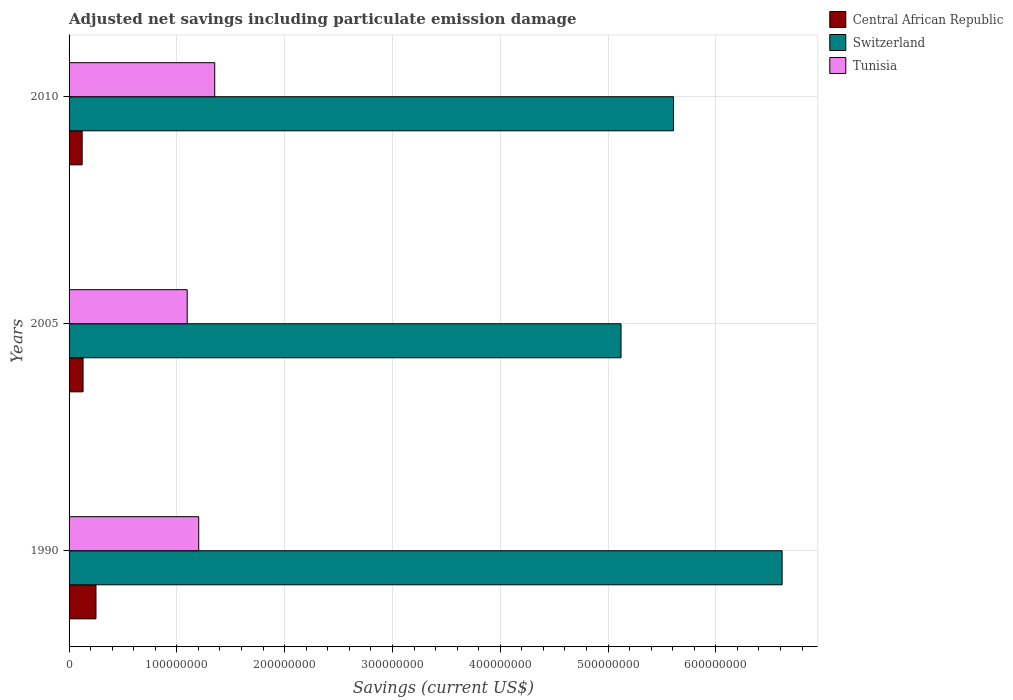How many different coloured bars are there?
Your response must be concise. 3. Are the number of bars per tick equal to the number of legend labels?
Offer a very short reply. Yes. Are the number of bars on each tick of the Y-axis equal?
Provide a succinct answer. Yes. How many bars are there on the 1st tick from the bottom?
Your answer should be compact. 3. What is the label of the 2nd group of bars from the top?
Provide a short and direct response. 2005. In how many cases, is the number of bars for a given year not equal to the number of legend labels?
Offer a very short reply. 0. What is the net savings in Central African Republic in 2005?
Give a very brief answer. 1.30e+07. Across all years, what is the maximum net savings in Tunisia?
Your answer should be compact. 1.35e+08. Across all years, what is the minimum net savings in Switzerland?
Keep it short and to the point. 5.12e+08. In which year was the net savings in Central African Republic maximum?
Your answer should be very brief. 1990. What is the total net savings in Tunisia in the graph?
Your response must be concise. 3.65e+08. What is the difference between the net savings in Switzerland in 1990 and that in 2005?
Your response must be concise. 1.49e+08. What is the difference between the net savings in Central African Republic in 2010 and the net savings in Tunisia in 2005?
Make the answer very short. -9.74e+07. What is the average net savings in Central African Republic per year?
Ensure brevity in your answer.  1.67e+07. In the year 1990, what is the difference between the net savings in Central African Republic and net savings in Tunisia?
Give a very brief answer. -9.53e+07. In how many years, is the net savings in Tunisia greater than 540000000 US$?
Your response must be concise. 0. What is the ratio of the net savings in Switzerland in 2005 to that in 2010?
Ensure brevity in your answer.  0.91. Is the net savings in Switzerland in 2005 less than that in 2010?
Make the answer very short. Yes. What is the difference between the highest and the second highest net savings in Tunisia?
Your answer should be compact. 1.49e+07. What is the difference between the highest and the lowest net savings in Tunisia?
Give a very brief answer. 2.55e+07. In how many years, is the net savings in Switzerland greater than the average net savings in Switzerland taken over all years?
Offer a very short reply. 1. What does the 1st bar from the top in 2010 represents?
Offer a very short reply. Tunisia. What does the 2nd bar from the bottom in 1990 represents?
Offer a terse response. Switzerland. Is it the case that in every year, the sum of the net savings in Switzerland and net savings in Tunisia is greater than the net savings in Central African Republic?
Give a very brief answer. Yes. Are all the bars in the graph horizontal?
Keep it short and to the point. Yes. Are the values on the major ticks of X-axis written in scientific E-notation?
Give a very brief answer. No. Does the graph contain grids?
Offer a very short reply. Yes. How are the legend labels stacked?
Your response must be concise. Vertical. What is the title of the graph?
Keep it short and to the point. Adjusted net savings including particulate emission damage. What is the label or title of the X-axis?
Provide a succinct answer. Savings (current US$). What is the Savings (current US$) of Central African Republic in 1990?
Your answer should be very brief. 2.50e+07. What is the Savings (current US$) in Switzerland in 1990?
Offer a terse response. 6.61e+08. What is the Savings (current US$) of Tunisia in 1990?
Your answer should be compact. 1.20e+08. What is the Savings (current US$) of Central African Republic in 2005?
Provide a short and direct response. 1.30e+07. What is the Savings (current US$) of Switzerland in 2005?
Offer a terse response. 5.12e+08. What is the Savings (current US$) of Tunisia in 2005?
Your answer should be compact. 1.10e+08. What is the Savings (current US$) of Central African Republic in 2010?
Offer a terse response. 1.21e+07. What is the Savings (current US$) of Switzerland in 2010?
Offer a terse response. 5.61e+08. What is the Savings (current US$) in Tunisia in 2010?
Your answer should be compact. 1.35e+08. Across all years, what is the maximum Savings (current US$) in Central African Republic?
Your response must be concise. 2.50e+07. Across all years, what is the maximum Savings (current US$) of Switzerland?
Offer a very short reply. 6.61e+08. Across all years, what is the maximum Savings (current US$) in Tunisia?
Provide a succinct answer. 1.35e+08. Across all years, what is the minimum Savings (current US$) in Central African Republic?
Ensure brevity in your answer.  1.21e+07. Across all years, what is the minimum Savings (current US$) of Switzerland?
Offer a terse response. 5.12e+08. Across all years, what is the minimum Savings (current US$) of Tunisia?
Offer a very short reply. 1.10e+08. What is the total Savings (current US$) of Central African Republic in the graph?
Offer a terse response. 5.01e+07. What is the total Savings (current US$) of Switzerland in the graph?
Your answer should be very brief. 1.73e+09. What is the total Savings (current US$) in Tunisia in the graph?
Offer a terse response. 3.65e+08. What is the difference between the Savings (current US$) in Central African Republic in 1990 and that in 2005?
Your answer should be very brief. 1.20e+07. What is the difference between the Savings (current US$) in Switzerland in 1990 and that in 2005?
Give a very brief answer. 1.49e+08. What is the difference between the Savings (current US$) of Tunisia in 1990 and that in 2005?
Keep it short and to the point. 1.07e+07. What is the difference between the Savings (current US$) of Central African Republic in 1990 and that in 2010?
Your answer should be very brief. 1.28e+07. What is the difference between the Savings (current US$) in Switzerland in 1990 and that in 2010?
Offer a very short reply. 1.01e+08. What is the difference between the Savings (current US$) of Tunisia in 1990 and that in 2010?
Offer a terse response. -1.49e+07. What is the difference between the Savings (current US$) in Central African Republic in 2005 and that in 2010?
Give a very brief answer. 8.31e+05. What is the difference between the Savings (current US$) in Switzerland in 2005 and that in 2010?
Make the answer very short. -4.87e+07. What is the difference between the Savings (current US$) of Tunisia in 2005 and that in 2010?
Provide a short and direct response. -2.55e+07. What is the difference between the Savings (current US$) of Central African Republic in 1990 and the Savings (current US$) of Switzerland in 2005?
Make the answer very short. -4.87e+08. What is the difference between the Savings (current US$) of Central African Republic in 1990 and the Savings (current US$) of Tunisia in 2005?
Give a very brief answer. -8.46e+07. What is the difference between the Savings (current US$) in Switzerland in 1990 and the Savings (current US$) in Tunisia in 2005?
Provide a succinct answer. 5.52e+08. What is the difference between the Savings (current US$) of Central African Republic in 1990 and the Savings (current US$) of Switzerland in 2010?
Provide a short and direct response. -5.36e+08. What is the difference between the Savings (current US$) in Central African Republic in 1990 and the Savings (current US$) in Tunisia in 2010?
Ensure brevity in your answer.  -1.10e+08. What is the difference between the Savings (current US$) of Switzerland in 1990 and the Savings (current US$) of Tunisia in 2010?
Make the answer very short. 5.26e+08. What is the difference between the Savings (current US$) of Central African Republic in 2005 and the Savings (current US$) of Switzerland in 2010?
Ensure brevity in your answer.  -5.48e+08. What is the difference between the Savings (current US$) in Central African Republic in 2005 and the Savings (current US$) in Tunisia in 2010?
Keep it short and to the point. -1.22e+08. What is the difference between the Savings (current US$) of Switzerland in 2005 and the Savings (current US$) of Tunisia in 2010?
Offer a very short reply. 3.77e+08. What is the average Savings (current US$) of Central African Republic per year?
Your response must be concise. 1.67e+07. What is the average Savings (current US$) in Switzerland per year?
Provide a succinct answer. 5.78e+08. What is the average Savings (current US$) of Tunisia per year?
Your response must be concise. 1.22e+08. In the year 1990, what is the difference between the Savings (current US$) in Central African Republic and Savings (current US$) in Switzerland?
Your answer should be very brief. -6.37e+08. In the year 1990, what is the difference between the Savings (current US$) in Central African Republic and Savings (current US$) in Tunisia?
Offer a very short reply. -9.53e+07. In the year 1990, what is the difference between the Savings (current US$) of Switzerland and Savings (current US$) of Tunisia?
Make the answer very short. 5.41e+08. In the year 2005, what is the difference between the Savings (current US$) of Central African Republic and Savings (current US$) of Switzerland?
Ensure brevity in your answer.  -4.99e+08. In the year 2005, what is the difference between the Savings (current US$) in Central African Republic and Savings (current US$) in Tunisia?
Provide a succinct answer. -9.66e+07. In the year 2005, what is the difference between the Savings (current US$) of Switzerland and Savings (current US$) of Tunisia?
Ensure brevity in your answer.  4.02e+08. In the year 2010, what is the difference between the Savings (current US$) of Central African Republic and Savings (current US$) of Switzerland?
Keep it short and to the point. -5.49e+08. In the year 2010, what is the difference between the Savings (current US$) of Central African Republic and Savings (current US$) of Tunisia?
Keep it short and to the point. -1.23e+08. In the year 2010, what is the difference between the Savings (current US$) of Switzerland and Savings (current US$) of Tunisia?
Ensure brevity in your answer.  4.26e+08. What is the ratio of the Savings (current US$) of Central African Republic in 1990 to that in 2005?
Your answer should be compact. 1.92. What is the ratio of the Savings (current US$) in Switzerland in 1990 to that in 2005?
Provide a succinct answer. 1.29. What is the ratio of the Savings (current US$) of Tunisia in 1990 to that in 2005?
Keep it short and to the point. 1.1. What is the ratio of the Savings (current US$) in Central African Republic in 1990 to that in 2010?
Your answer should be very brief. 2.06. What is the ratio of the Savings (current US$) in Switzerland in 1990 to that in 2010?
Your response must be concise. 1.18. What is the ratio of the Savings (current US$) in Tunisia in 1990 to that in 2010?
Your answer should be very brief. 0.89. What is the ratio of the Savings (current US$) of Central African Republic in 2005 to that in 2010?
Your answer should be very brief. 1.07. What is the ratio of the Savings (current US$) of Switzerland in 2005 to that in 2010?
Ensure brevity in your answer.  0.91. What is the ratio of the Savings (current US$) of Tunisia in 2005 to that in 2010?
Your answer should be compact. 0.81. What is the difference between the highest and the second highest Savings (current US$) in Central African Republic?
Give a very brief answer. 1.20e+07. What is the difference between the highest and the second highest Savings (current US$) in Switzerland?
Give a very brief answer. 1.01e+08. What is the difference between the highest and the second highest Savings (current US$) of Tunisia?
Provide a short and direct response. 1.49e+07. What is the difference between the highest and the lowest Savings (current US$) in Central African Republic?
Keep it short and to the point. 1.28e+07. What is the difference between the highest and the lowest Savings (current US$) in Switzerland?
Your answer should be very brief. 1.49e+08. What is the difference between the highest and the lowest Savings (current US$) in Tunisia?
Provide a succinct answer. 2.55e+07. 